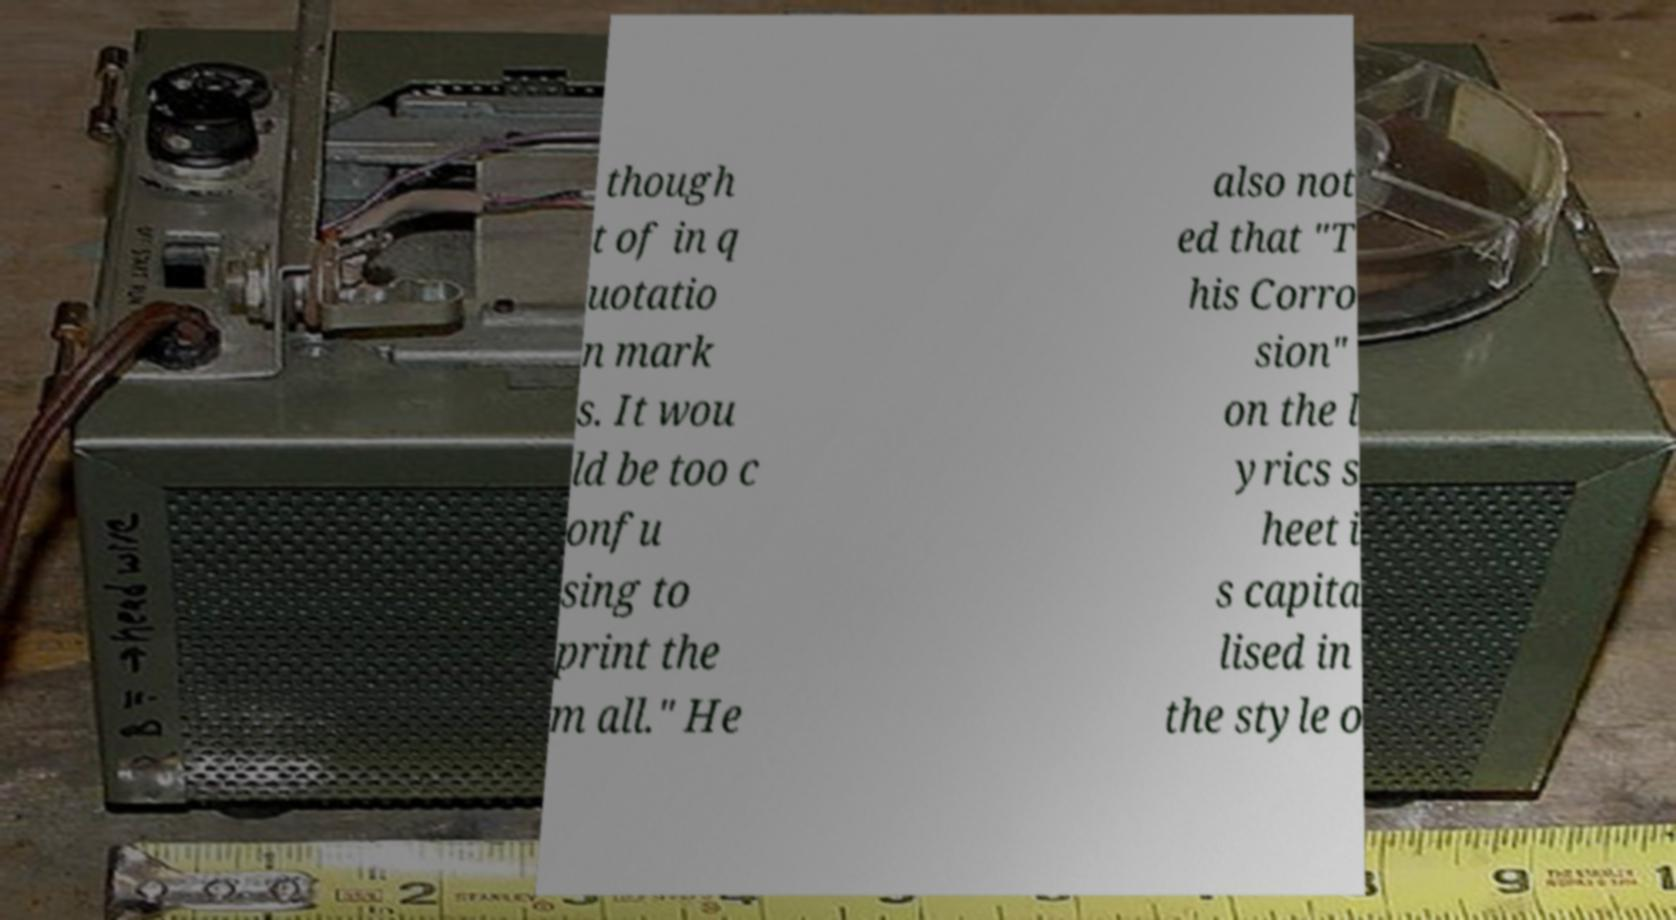There's text embedded in this image that I need extracted. Can you transcribe it verbatim? though t of in q uotatio n mark s. It wou ld be too c onfu sing to print the m all." He also not ed that "T his Corro sion" on the l yrics s heet i s capita lised in the style o 